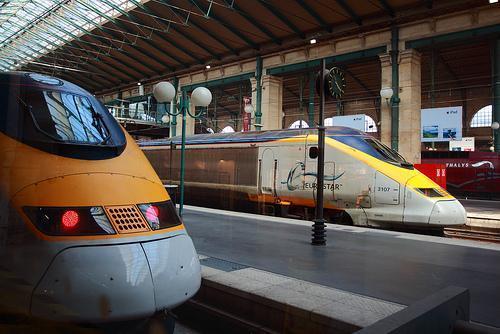How many trains are in the station?
Give a very brief answer. 2. How many people are standing near the train?
Give a very brief answer. 0. 